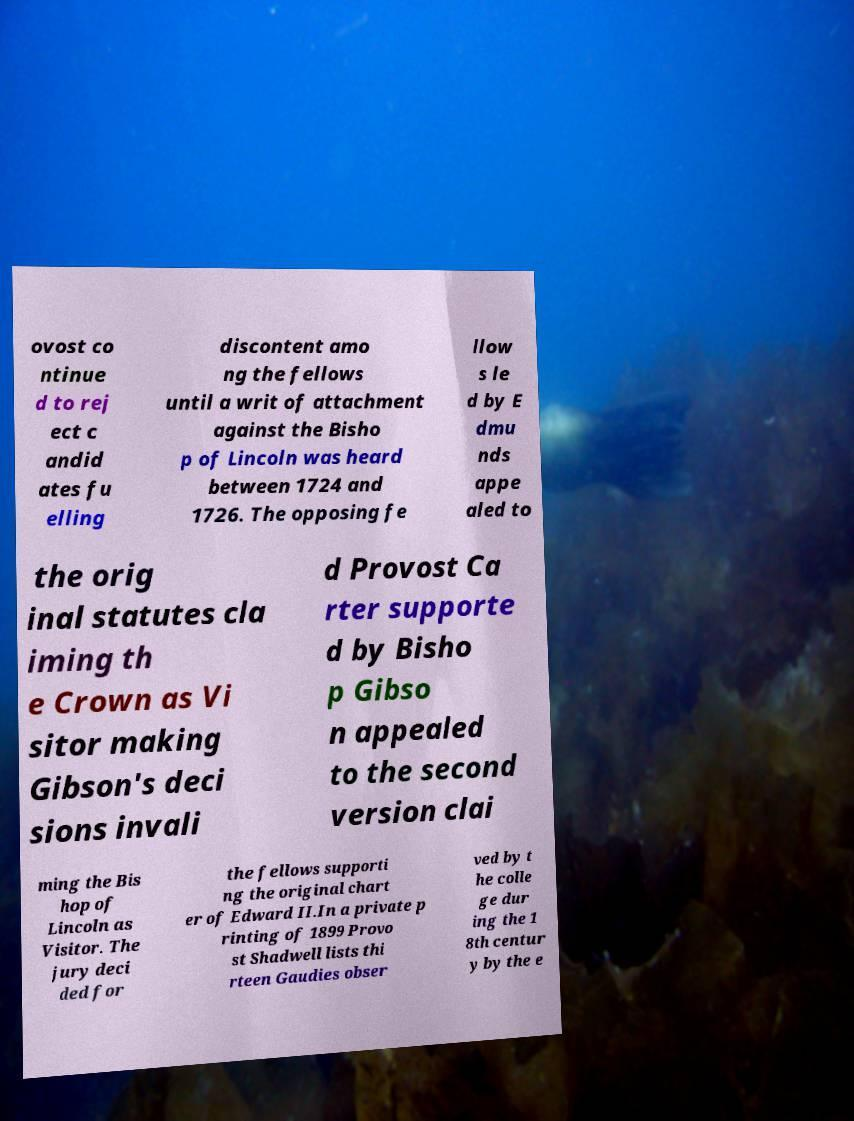Please identify and transcribe the text found in this image. ovost co ntinue d to rej ect c andid ates fu elling discontent amo ng the fellows until a writ of attachment against the Bisho p of Lincoln was heard between 1724 and 1726. The opposing fe llow s le d by E dmu nds appe aled to the orig inal statutes cla iming th e Crown as Vi sitor making Gibson's deci sions invali d Provost Ca rter supporte d by Bisho p Gibso n appealed to the second version clai ming the Bis hop of Lincoln as Visitor. The jury deci ded for the fellows supporti ng the original chart er of Edward II.In a private p rinting of 1899 Provo st Shadwell lists thi rteen Gaudies obser ved by t he colle ge dur ing the 1 8th centur y by the e 